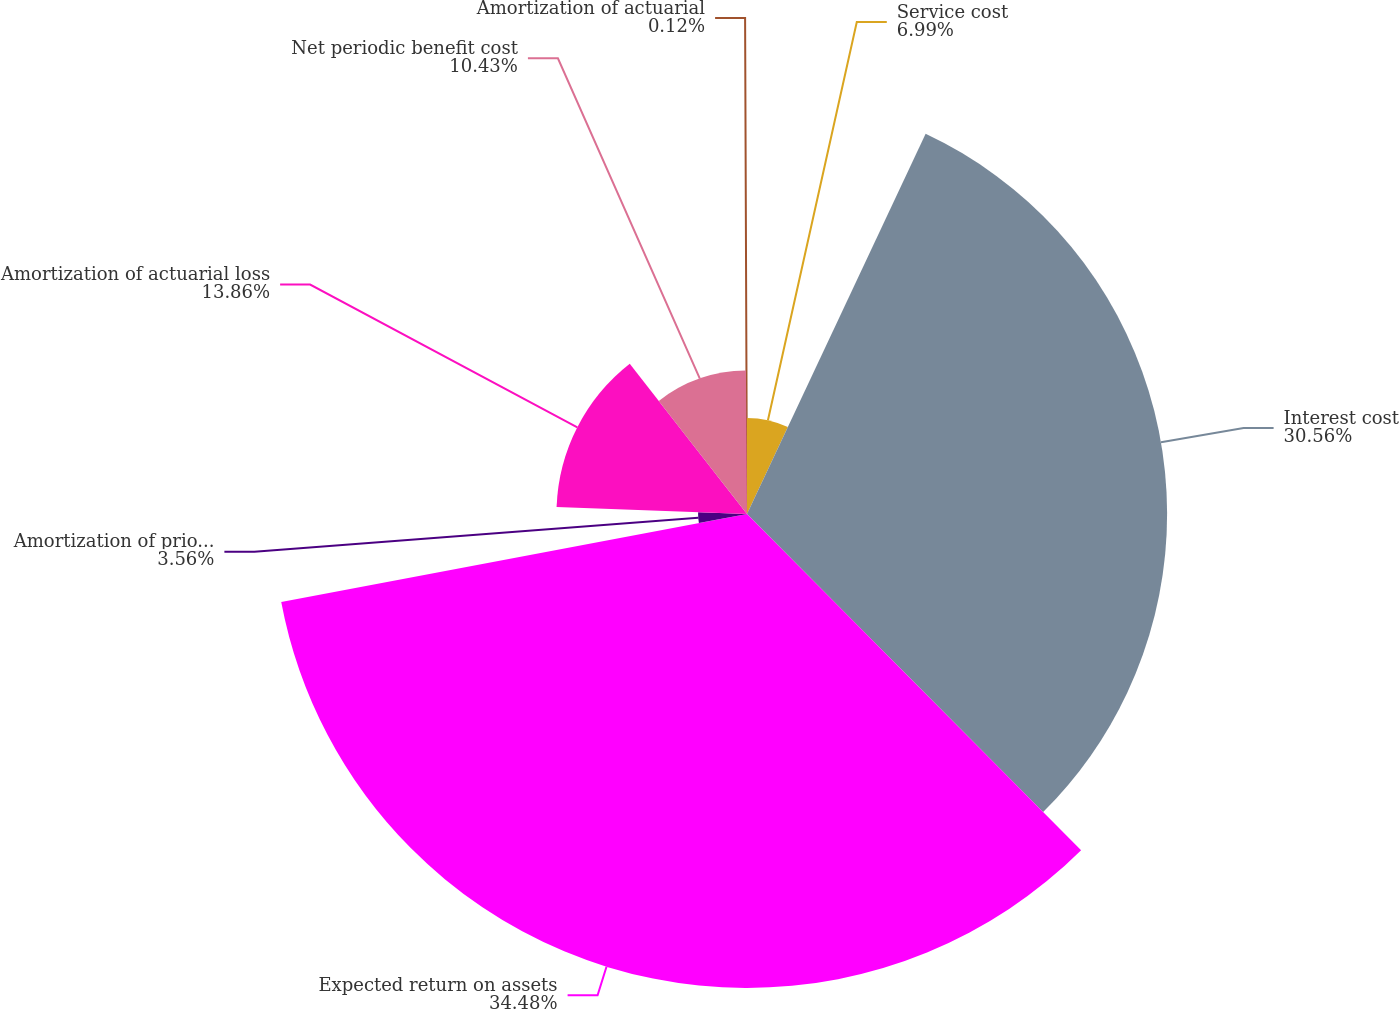Convert chart. <chart><loc_0><loc_0><loc_500><loc_500><pie_chart><fcel>Service cost<fcel>Interest cost<fcel>Expected return on assets<fcel>Amortization of prior service<fcel>Amortization of actuarial loss<fcel>Net periodic benefit cost<fcel>Amortization of actuarial<nl><fcel>6.99%<fcel>30.56%<fcel>34.48%<fcel>3.56%<fcel>13.86%<fcel>10.43%<fcel>0.12%<nl></chart> 